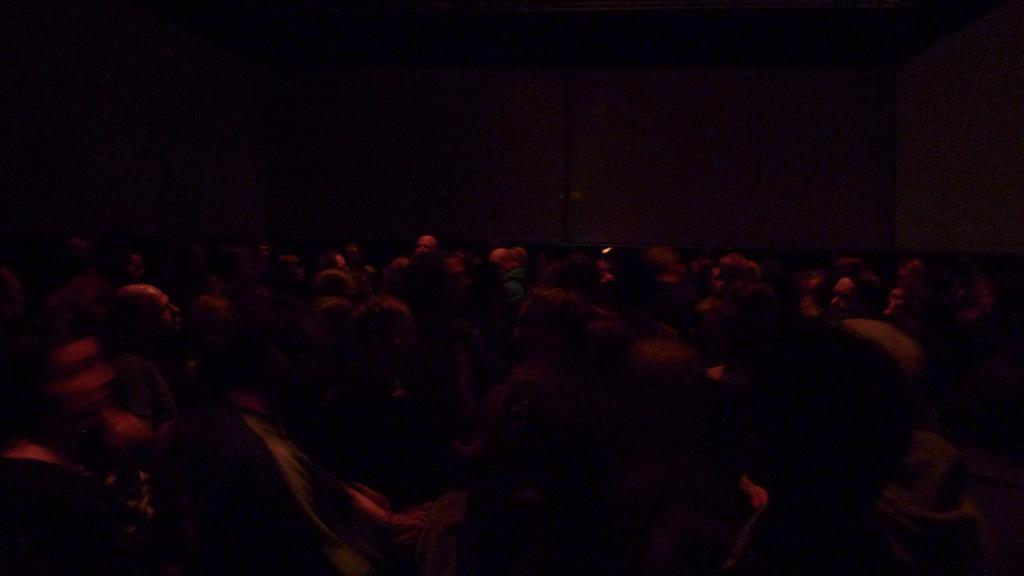How many people are in the image? There is a group of people in the image. What are the people in the image doing? The people are standing. What can be seen in the background of the image? There is a wall in the background of the image. What type of magic is the uncle performing in the image? There is no uncle or magic present in the image. How many breaths can be counted coming from the people in the image? It is not possible to count breaths from the people in the image, as it is a still photograph. 